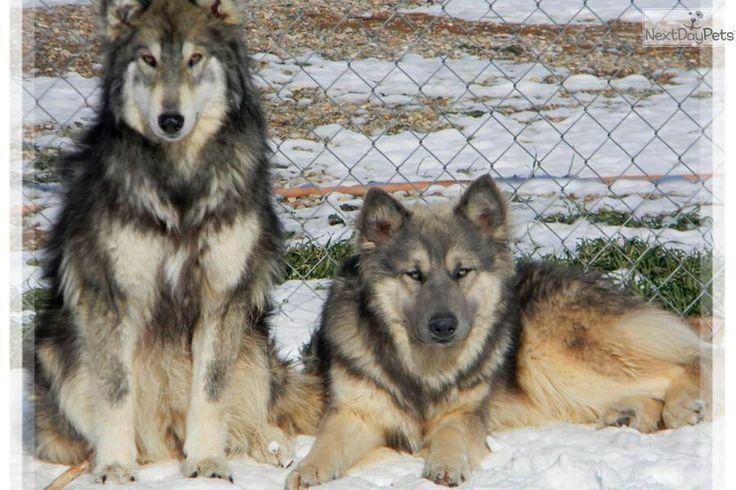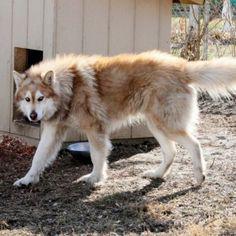The first image is the image on the left, the second image is the image on the right. Assess this claim about the two images: "There is a single dog with its mouth open in the right image.". Correct or not? Answer yes or no. No. 